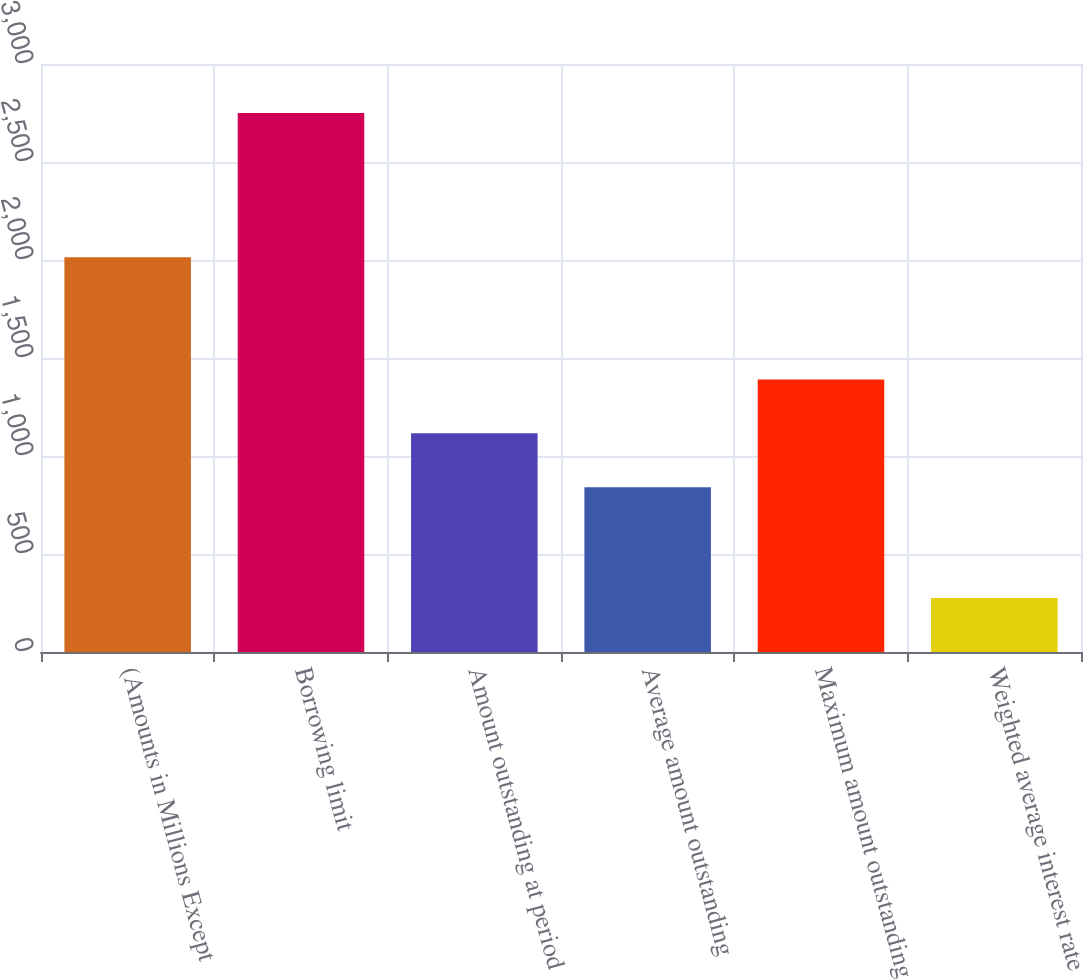Convert chart. <chart><loc_0><loc_0><loc_500><loc_500><bar_chart><fcel>(Amounts in Millions Except<fcel>Borrowing limit<fcel>Amount outstanding at period<fcel>Average amount outstanding<fcel>Maximum amount outstanding<fcel>Weighted average interest rate<nl><fcel>2014<fcel>2750<fcel>1115.97<fcel>841<fcel>1390.94<fcel>275.3<nl></chart> 